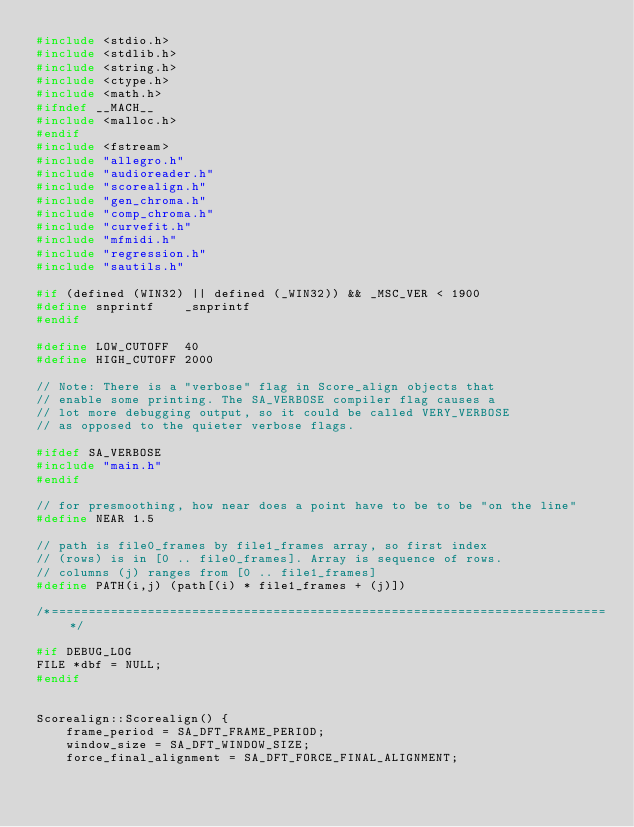Convert code to text. <code><loc_0><loc_0><loc_500><loc_500><_C++_>#include <stdio.h>
#include <stdlib.h>
#include <string.h>
#include <ctype.h>
#include <math.h>
#ifndef __MACH__
#include <malloc.h>
#endif
#include <fstream>
#include "allegro.h"
#include "audioreader.h"
#include "scorealign.h"
#include "gen_chroma.h"
#include "comp_chroma.h"
#include "curvefit.h"
#include "mfmidi.h"
#include "regression.h"
#include "sautils.h"

#if (defined (WIN32) || defined (_WIN32)) && _MSC_VER < 1900
#define	snprintf	_snprintf
#endif

#define	LOW_CUTOFF  40
#define HIGH_CUTOFF 2000

// Note: There is a "verbose" flag in Score_align objects that
// enable some printing. The SA_VERBOSE compiler flag causes a
// lot more debugging output, so it could be called VERY_VERBOSE
// as opposed to the quieter verbose flags.

#ifdef SA_VERBOSE
#include "main.h"
#endif

// for presmoothing, how near does a point have to be to be "on the line"
#define NEAR 1.5

// path is file0_frames by file1_frames array, so first index
// (rows) is in [0 .. file0_frames]. Array is sequence of rows.
// columns (j) ranges from [0 .. file1_frames]
#define PATH(i,j) (path[(i) * file1_frames + (j)])

/*===========================================================================*/

#if DEBUG_LOG
FILE *dbf = NULL;
#endif


Scorealign::Scorealign() {
    frame_period = SA_DFT_FRAME_PERIOD;
    window_size = SA_DFT_WINDOW_SIZE;
    force_final_alignment = SA_DFT_FORCE_FINAL_ALIGNMENT;</code> 